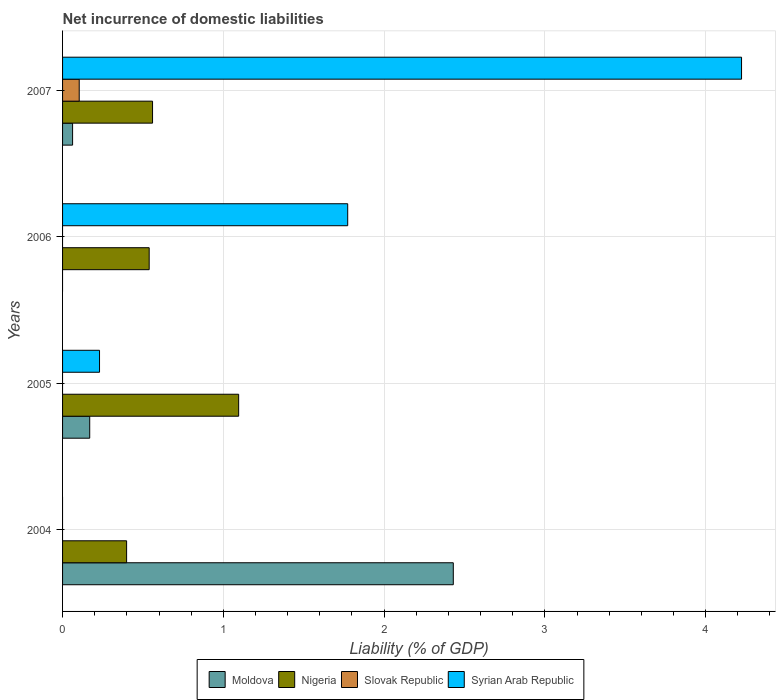How many groups of bars are there?
Offer a very short reply. 4. Are the number of bars on each tick of the Y-axis equal?
Your response must be concise. No. What is the label of the 1st group of bars from the top?
Provide a succinct answer. 2007. Across all years, what is the maximum net incurrence of domestic liabilities in Moldova?
Give a very brief answer. 2.43. Across all years, what is the minimum net incurrence of domestic liabilities in Nigeria?
Provide a succinct answer. 0.4. In which year was the net incurrence of domestic liabilities in Syrian Arab Republic maximum?
Your answer should be very brief. 2007. What is the total net incurrence of domestic liabilities in Syrian Arab Republic in the graph?
Keep it short and to the point. 6.23. What is the difference between the net incurrence of domestic liabilities in Nigeria in 2005 and that in 2006?
Offer a very short reply. 0.56. What is the difference between the net incurrence of domestic liabilities in Slovak Republic in 2004 and the net incurrence of domestic liabilities in Syrian Arab Republic in 2005?
Provide a short and direct response. -0.23. What is the average net incurrence of domestic liabilities in Nigeria per year?
Your response must be concise. 0.65. In the year 2007, what is the difference between the net incurrence of domestic liabilities in Moldova and net incurrence of domestic liabilities in Nigeria?
Give a very brief answer. -0.5. What is the ratio of the net incurrence of domestic liabilities in Moldova in 2005 to that in 2007?
Make the answer very short. 2.71. Is the difference between the net incurrence of domestic liabilities in Moldova in 2004 and 2007 greater than the difference between the net incurrence of domestic liabilities in Nigeria in 2004 and 2007?
Give a very brief answer. Yes. What is the difference between the highest and the second highest net incurrence of domestic liabilities in Moldova?
Offer a very short reply. 2.26. What is the difference between the highest and the lowest net incurrence of domestic liabilities in Nigeria?
Ensure brevity in your answer.  0.7. In how many years, is the net incurrence of domestic liabilities in Slovak Republic greater than the average net incurrence of domestic liabilities in Slovak Republic taken over all years?
Your answer should be very brief. 1. Is the sum of the net incurrence of domestic liabilities in Nigeria in 2004 and 2005 greater than the maximum net incurrence of domestic liabilities in Slovak Republic across all years?
Offer a terse response. Yes. Are all the bars in the graph horizontal?
Your answer should be very brief. Yes. How many years are there in the graph?
Provide a succinct answer. 4. Are the values on the major ticks of X-axis written in scientific E-notation?
Keep it short and to the point. No. How many legend labels are there?
Provide a short and direct response. 4. What is the title of the graph?
Provide a short and direct response. Net incurrence of domestic liabilities. Does "Indonesia" appear as one of the legend labels in the graph?
Offer a terse response. No. What is the label or title of the X-axis?
Your answer should be very brief. Liability (% of GDP). What is the Liability (% of GDP) in Moldova in 2004?
Provide a short and direct response. 2.43. What is the Liability (% of GDP) in Nigeria in 2004?
Your response must be concise. 0.4. What is the Liability (% of GDP) of Syrian Arab Republic in 2004?
Provide a succinct answer. 0. What is the Liability (% of GDP) in Moldova in 2005?
Give a very brief answer. 0.17. What is the Liability (% of GDP) of Nigeria in 2005?
Provide a succinct answer. 1.1. What is the Liability (% of GDP) in Syrian Arab Republic in 2005?
Provide a succinct answer. 0.23. What is the Liability (% of GDP) in Nigeria in 2006?
Your response must be concise. 0.54. What is the Liability (% of GDP) of Syrian Arab Republic in 2006?
Give a very brief answer. 1.77. What is the Liability (% of GDP) of Moldova in 2007?
Your answer should be compact. 0.06. What is the Liability (% of GDP) of Nigeria in 2007?
Give a very brief answer. 0.56. What is the Liability (% of GDP) of Slovak Republic in 2007?
Offer a terse response. 0.1. What is the Liability (% of GDP) of Syrian Arab Republic in 2007?
Offer a very short reply. 4.22. Across all years, what is the maximum Liability (% of GDP) of Moldova?
Offer a very short reply. 2.43. Across all years, what is the maximum Liability (% of GDP) of Nigeria?
Your answer should be compact. 1.1. Across all years, what is the maximum Liability (% of GDP) in Slovak Republic?
Make the answer very short. 0.1. Across all years, what is the maximum Liability (% of GDP) in Syrian Arab Republic?
Provide a short and direct response. 4.22. Across all years, what is the minimum Liability (% of GDP) of Nigeria?
Offer a very short reply. 0.4. Across all years, what is the minimum Liability (% of GDP) of Syrian Arab Republic?
Your response must be concise. 0. What is the total Liability (% of GDP) of Moldova in the graph?
Ensure brevity in your answer.  2.66. What is the total Liability (% of GDP) of Nigeria in the graph?
Your answer should be very brief. 2.59. What is the total Liability (% of GDP) of Slovak Republic in the graph?
Your response must be concise. 0.1. What is the total Liability (% of GDP) in Syrian Arab Republic in the graph?
Offer a very short reply. 6.23. What is the difference between the Liability (% of GDP) of Moldova in 2004 and that in 2005?
Keep it short and to the point. 2.26. What is the difference between the Liability (% of GDP) in Nigeria in 2004 and that in 2005?
Offer a terse response. -0.7. What is the difference between the Liability (% of GDP) of Nigeria in 2004 and that in 2006?
Offer a very short reply. -0.14. What is the difference between the Liability (% of GDP) of Moldova in 2004 and that in 2007?
Offer a very short reply. 2.37. What is the difference between the Liability (% of GDP) in Nigeria in 2004 and that in 2007?
Provide a short and direct response. -0.16. What is the difference between the Liability (% of GDP) of Nigeria in 2005 and that in 2006?
Give a very brief answer. 0.56. What is the difference between the Liability (% of GDP) in Syrian Arab Republic in 2005 and that in 2006?
Offer a terse response. -1.54. What is the difference between the Liability (% of GDP) in Moldova in 2005 and that in 2007?
Your answer should be compact. 0.11. What is the difference between the Liability (% of GDP) in Nigeria in 2005 and that in 2007?
Offer a terse response. 0.54. What is the difference between the Liability (% of GDP) in Syrian Arab Republic in 2005 and that in 2007?
Give a very brief answer. -3.99. What is the difference between the Liability (% of GDP) of Nigeria in 2006 and that in 2007?
Make the answer very short. -0.02. What is the difference between the Liability (% of GDP) of Syrian Arab Republic in 2006 and that in 2007?
Your response must be concise. -2.45. What is the difference between the Liability (% of GDP) of Moldova in 2004 and the Liability (% of GDP) of Nigeria in 2005?
Ensure brevity in your answer.  1.34. What is the difference between the Liability (% of GDP) in Moldova in 2004 and the Liability (% of GDP) in Syrian Arab Republic in 2005?
Keep it short and to the point. 2.2. What is the difference between the Liability (% of GDP) in Nigeria in 2004 and the Liability (% of GDP) in Syrian Arab Republic in 2005?
Make the answer very short. 0.17. What is the difference between the Liability (% of GDP) of Moldova in 2004 and the Liability (% of GDP) of Nigeria in 2006?
Provide a succinct answer. 1.89. What is the difference between the Liability (% of GDP) in Moldova in 2004 and the Liability (% of GDP) in Syrian Arab Republic in 2006?
Keep it short and to the point. 0.66. What is the difference between the Liability (% of GDP) of Nigeria in 2004 and the Liability (% of GDP) of Syrian Arab Republic in 2006?
Make the answer very short. -1.38. What is the difference between the Liability (% of GDP) in Moldova in 2004 and the Liability (% of GDP) in Nigeria in 2007?
Your answer should be compact. 1.87. What is the difference between the Liability (% of GDP) in Moldova in 2004 and the Liability (% of GDP) in Slovak Republic in 2007?
Offer a very short reply. 2.33. What is the difference between the Liability (% of GDP) in Moldova in 2004 and the Liability (% of GDP) in Syrian Arab Republic in 2007?
Keep it short and to the point. -1.79. What is the difference between the Liability (% of GDP) of Nigeria in 2004 and the Liability (% of GDP) of Slovak Republic in 2007?
Your answer should be very brief. 0.29. What is the difference between the Liability (% of GDP) of Nigeria in 2004 and the Liability (% of GDP) of Syrian Arab Republic in 2007?
Make the answer very short. -3.82. What is the difference between the Liability (% of GDP) in Moldova in 2005 and the Liability (% of GDP) in Nigeria in 2006?
Ensure brevity in your answer.  -0.37. What is the difference between the Liability (% of GDP) of Moldova in 2005 and the Liability (% of GDP) of Syrian Arab Republic in 2006?
Provide a short and direct response. -1.6. What is the difference between the Liability (% of GDP) in Nigeria in 2005 and the Liability (% of GDP) in Syrian Arab Republic in 2006?
Offer a terse response. -0.68. What is the difference between the Liability (% of GDP) in Moldova in 2005 and the Liability (% of GDP) in Nigeria in 2007?
Your response must be concise. -0.39. What is the difference between the Liability (% of GDP) of Moldova in 2005 and the Liability (% of GDP) of Slovak Republic in 2007?
Your answer should be compact. 0.07. What is the difference between the Liability (% of GDP) of Moldova in 2005 and the Liability (% of GDP) of Syrian Arab Republic in 2007?
Provide a short and direct response. -4.05. What is the difference between the Liability (% of GDP) of Nigeria in 2005 and the Liability (% of GDP) of Slovak Republic in 2007?
Offer a terse response. 0.99. What is the difference between the Liability (% of GDP) of Nigeria in 2005 and the Liability (% of GDP) of Syrian Arab Republic in 2007?
Offer a terse response. -3.13. What is the difference between the Liability (% of GDP) in Nigeria in 2006 and the Liability (% of GDP) in Slovak Republic in 2007?
Your answer should be very brief. 0.44. What is the difference between the Liability (% of GDP) in Nigeria in 2006 and the Liability (% of GDP) in Syrian Arab Republic in 2007?
Offer a very short reply. -3.68. What is the average Liability (% of GDP) in Moldova per year?
Make the answer very short. 0.67. What is the average Liability (% of GDP) of Nigeria per year?
Provide a succinct answer. 0.65. What is the average Liability (% of GDP) of Slovak Republic per year?
Give a very brief answer. 0.03. What is the average Liability (% of GDP) of Syrian Arab Republic per year?
Offer a terse response. 1.56. In the year 2004, what is the difference between the Liability (% of GDP) of Moldova and Liability (% of GDP) of Nigeria?
Your response must be concise. 2.03. In the year 2005, what is the difference between the Liability (% of GDP) of Moldova and Liability (% of GDP) of Nigeria?
Your response must be concise. -0.93. In the year 2005, what is the difference between the Liability (% of GDP) in Moldova and Liability (% of GDP) in Syrian Arab Republic?
Provide a succinct answer. -0.06. In the year 2005, what is the difference between the Liability (% of GDP) in Nigeria and Liability (% of GDP) in Syrian Arab Republic?
Your response must be concise. 0.87. In the year 2006, what is the difference between the Liability (% of GDP) in Nigeria and Liability (% of GDP) in Syrian Arab Republic?
Offer a terse response. -1.23. In the year 2007, what is the difference between the Liability (% of GDP) of Moldova and Liability (% of GDP) of Nigeria?
Ensure brevity in your answer.  -0.5. In the year 2007, what is the difference between the Liability (% of GDP) in Moldova and Liability (% of GDP) in Slovak Republic?
Your answer should be compact. -0.04. In the year 2007, what is the difference between the Liability (% of GDP) in Moldova and Liability (% of GDP) in Syrian Arab Republic?
Give a very brief answer. -4.16. In the year 2007, what is the difference between the Liability (% of GDP) in Nigeria and Liability (% of GDP) in Slovak Republic?
Your response must be concise. 0.46. In the year 2007, what is the difference between the Liability (% of GDP) of Nigeria and Liability (% of GDP) of Syrian Arab Republic?
Offer a very short reply. -3.66. In the year 2007, what is the difference between the Liability (% of GDP) of Slovak Republic and Liability (% of GDP) of Syrian Arab Republic?
Your answer should be compact. -4.12. What is the ratio of the Liability (% of GDP) in Moldova in 2004 to that in 2005?
Provide a succinct answer. 14.39. What is the ratio of the Liability (% of GDP) in Nigeria in 2004 to that in 2005?
Your response must be concise. 0.36. What is the ratio of the Liability (% of GDP) in Nigeria in 2004 to that in 2006?
Provide a short and direct response. 0.74. What is the ratio of the Liability (% of GDP) in Moldova in 2004 to that in 2007?
Offer a very short reply. 39. What is the ratio of the Liability (% of GDP) in Nigeria in 2004 to that in 2007?
Your answer should be very brief. 0.71. What is the ratio of the Liability (% of GDP) of Nigeria in 2005 to that in 2006?
Keep it short and to the point. 2.03. What is the ratio of the Liability (% of GDP) of Syrian Arab Republic in 2005 to that in 2006?
Offer a very short reply. 0.13. What is the ratio of the Liability (% of GDP) in Moldova in 2005 to that in 2007?
Your answer should be compact. 2.71. What is the ratio of the Liability (% of GDP) in Nigeria in 2005 to that in 2007?
Offer a very short reply. 1.96. What is the ratio of the Liability (% of GDP) of Syrian Arab Republic in 2005 to that in 2007?
Offer a terse response. 0.05. What is the ratio of the Liability (% of GDP) of Nigeria in 2006 to that in 2007?
Your answer should be very brief. 0.96. What is the ratio of the Liability (% of GDP) of Syrian Arab Republic in 2006 to that in 2007?
Your response must be concise. 0.42. What is the difference between the highest and the second highest Liability (% of GDP) in Moldova?
Offer a terse response. 2.26. What is the difference between the highest and the second highest Liability (% of GDP) of Nigeria?
Make the answer very short. 0.54. What is the difference between the highest and the second highest Liability (% of GDP) of Syrian Arab Republic?
Your answer should be very brief. 2.45. What is the difference between the highest and the lowest Liability (% of GDP) of Moldova?
Offer a terse response. 2.43. What is the difference between the highest and the lowest Liability (% of GDP) in Nigeria?
Provide a succinct answer. 0.7. What is the difference between the highest and the lowest Liability (% of GDP) of Slovak Republic?
Make the answer very short. 0.1. What is the difference between the highest and the lowest Liability (% of GDP) of Syrian Arab Republic?
Make the answer very short. 4.22. 